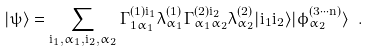Convert formula to latex. <formula><loc_0><loc_0><loc_500><loc_500>| \psi \rangle = \sum _ { i _ { 1 } , \alpha _ { 1 } , i _ { 2 } , \alpha _ { 2 } } \Gamma ^ { ( 1 ) i _ { 1 } } _ { 1 \alpha _ { 1 } } \lambda ^ { ( 1 ) } _ { \alpha _ { 1 } } \Gamma ^ { ( 2 ) i _ { 2 } } _ { \alpha _ { 1 } \alpha _ { 2 } } \lambda ^ { ( 2 ) } _ { \alpha _ { 2 } } | i _ { 1 } i _ { 2 } \rangle | \phi ^ { ( 3 \cdots n ) } _ { \alpha _ { 2 } } \rangle \ .</formula> 